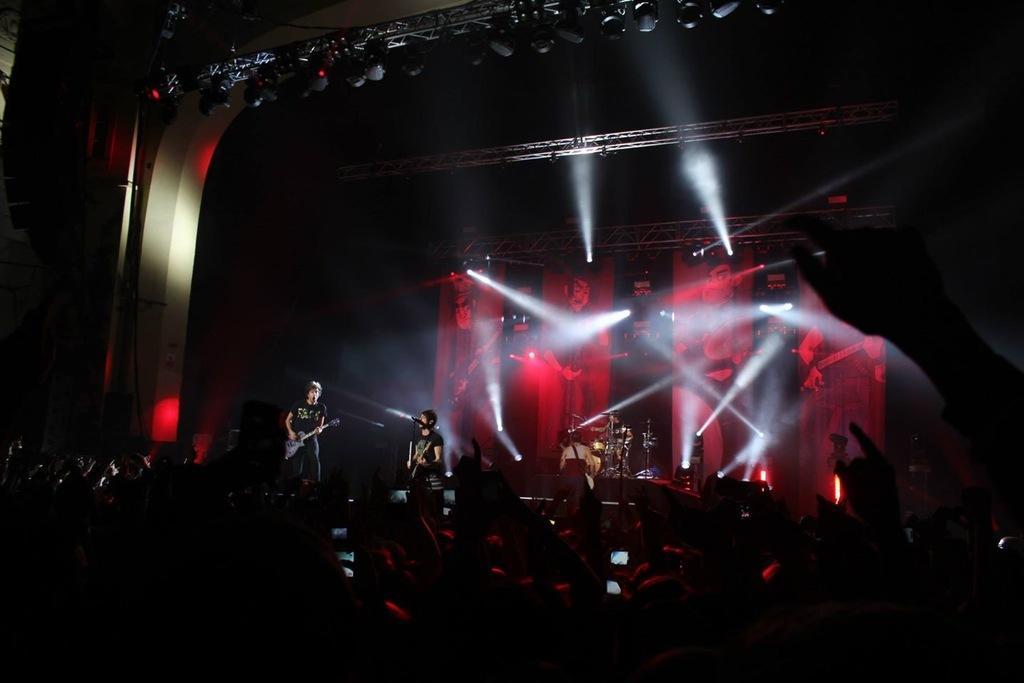Please provide a concise description of this image. In this picture we can see two persons are performing on the stage, at the bottom we can see some people, two persons on the stage are playing guitars, we can see cymbals and a drum in the background, it looks like a screen in the background, there are some lights in the middle. 